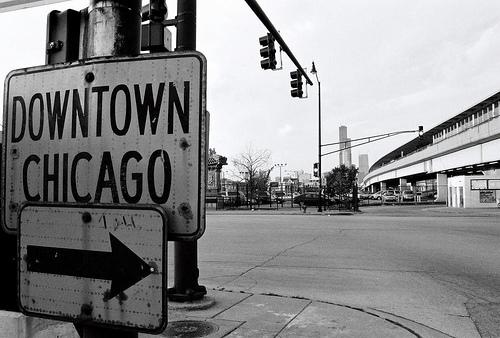What is the arrow in the sign trying to tell motorists?
Quick response, please. Direction. What time was this picture taken?
Quick response, please. Daytime. Where was this photo taken?
Short answer required. Chicago. 